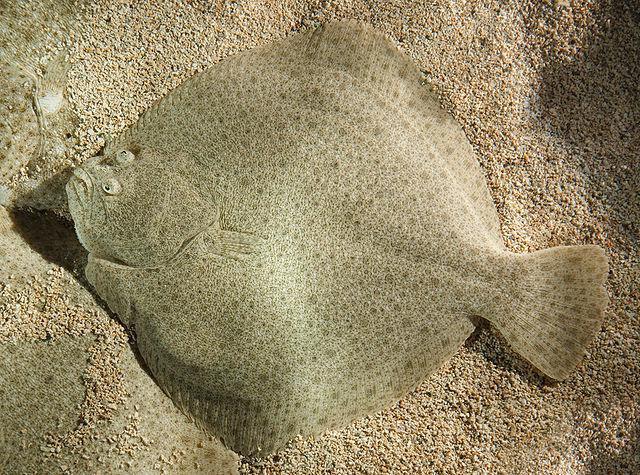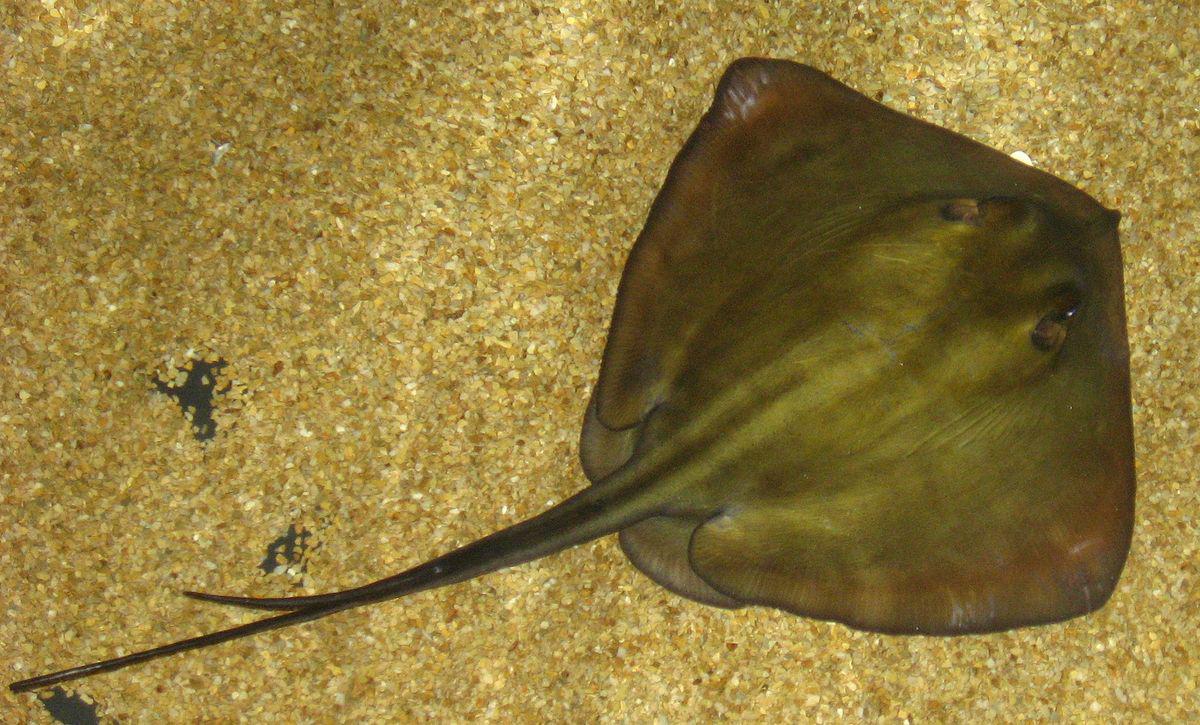The first image is the image on the left, the second image is the image on the right. Given the left and right images, does the statement "There is a stingray with its tail going towards a bottom corner." hold true? Answer yes or no. Yes. 